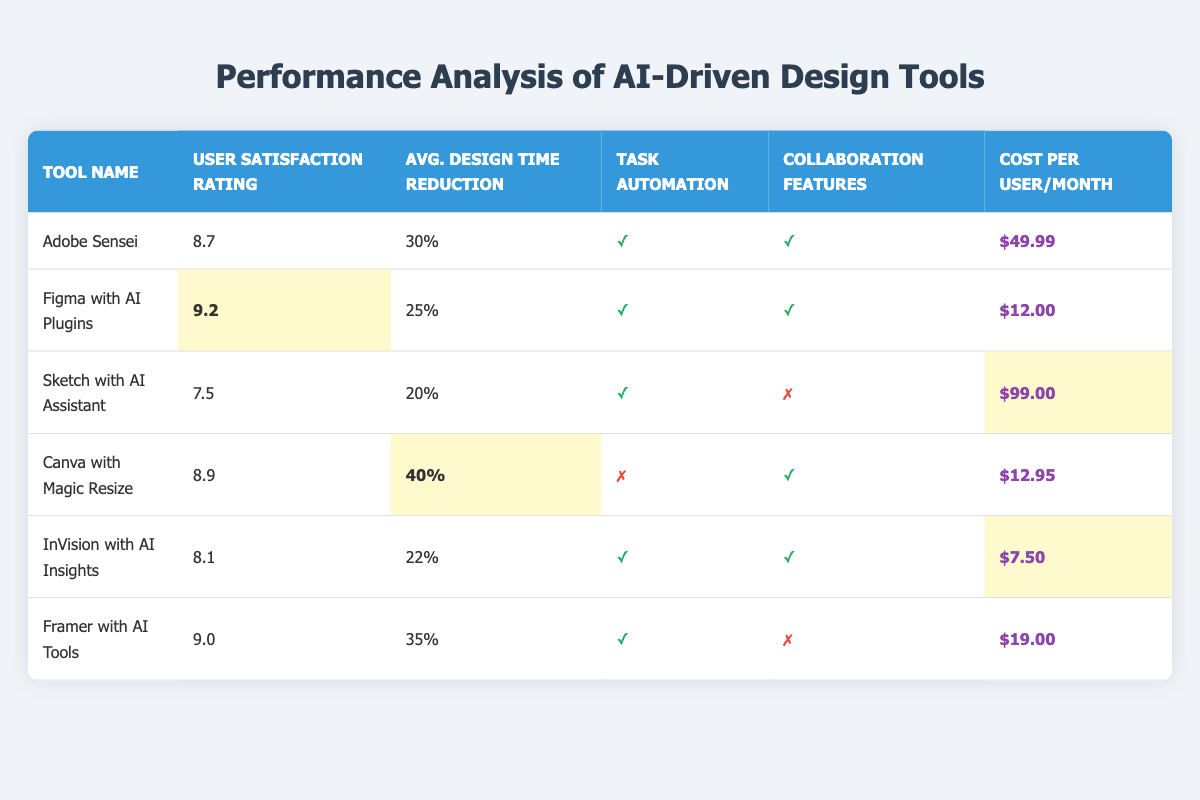What is the user satisfaction rating of Canva with Magic Resize? The user satisfaction rating column for Canva with Magic Resize shows a value of 8.9.
Answer: 8.9 Which tool has the highest average design time reduction percentage? The average design time reduction percentage for Canva with Magic Resize is 40%, which is higher than all other tools listed.
Answer: Canva with Magic Resize Did Sketch with AI Assistant enable task automation? The task automation column for Sketch with AI Assistant shows a checkmark (✓), indicating that it does enable task automation.
Answer: Yes What is the cost per user per month for InVision with AI Insights? The cost per user per month for InVision with AI Insights is listed as $7.50.
Answer: $7.50 Which tool has the lowest user satisfaction rating and what is that rating? Among the tools listed, Sketch with AI Assistant has the lowest user satisfaction rating of 7.5.
Answer: 7.5 How many tools have collaboration features enabled? The tools with collaboration features are Adobe Sensei, Figma with AI Plugins, Canva with Magic Resize, and InVision with AI Insights, which totals four tools.
Answer: 4 What is the average user satisfaction rating of the tools that enable task automation? The user satisfaction ratings for tools that enable task automation are 8.7 (Adobe Sensei), 9.2 (Figma), 7.5 (Sketch), 8.1 (InVision), and 9.0 (Framer). Adding these ratings gives 8.7 + 9.2 + 7.5 + 8.1 + 9.0 = 42.5. Dividing by 5 (the total number of tools) results in an average user satisfaction rating of 8.5.
Answer: 8.5 Which tool offers the most affordable cost at $12 or less? The tools priced at $12 or less are Figma with AI Plugins at $12 and InVision with AI Insights at $7.50, but only InVision meets the criteria for being the most affordable.
Answer: InVision with AI Insights How much cost difference is there between Adobe Sensei and Figma with AI Plugins? The cost of Adobe Sensei is $49.99 and for Figma with AI Plugins, it is $12. The cost difference is $49.99 - $12 = $37.99.
Answer: $37.99 What is the user satisfaction rating of the tool that has a 35% average design time reduction? The tool with a 35% average design time reduction is Framer with AI Tools, which has a user satisfaction rating of 9.0.
Answer: 9.0 How many tools have both task automation and collaboration features enabled? The tools that have both task automation and collaboration features enabled are Adobe Sensei, Figma with AI Plugins, and InVision with AI Insights, totaling three tools.
Answer: 3 